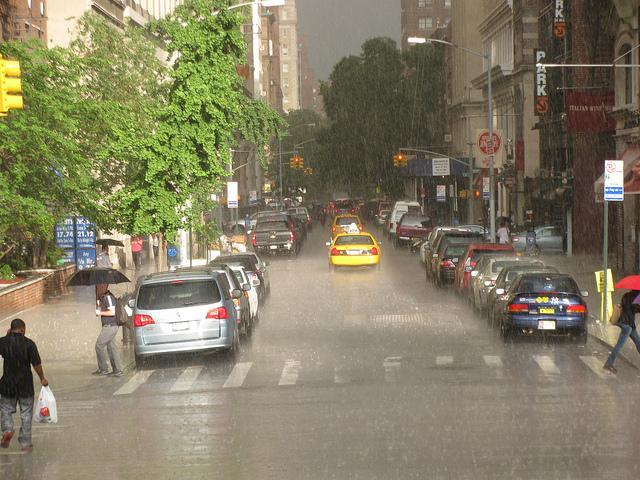What type markings are shown here? crosswalk 